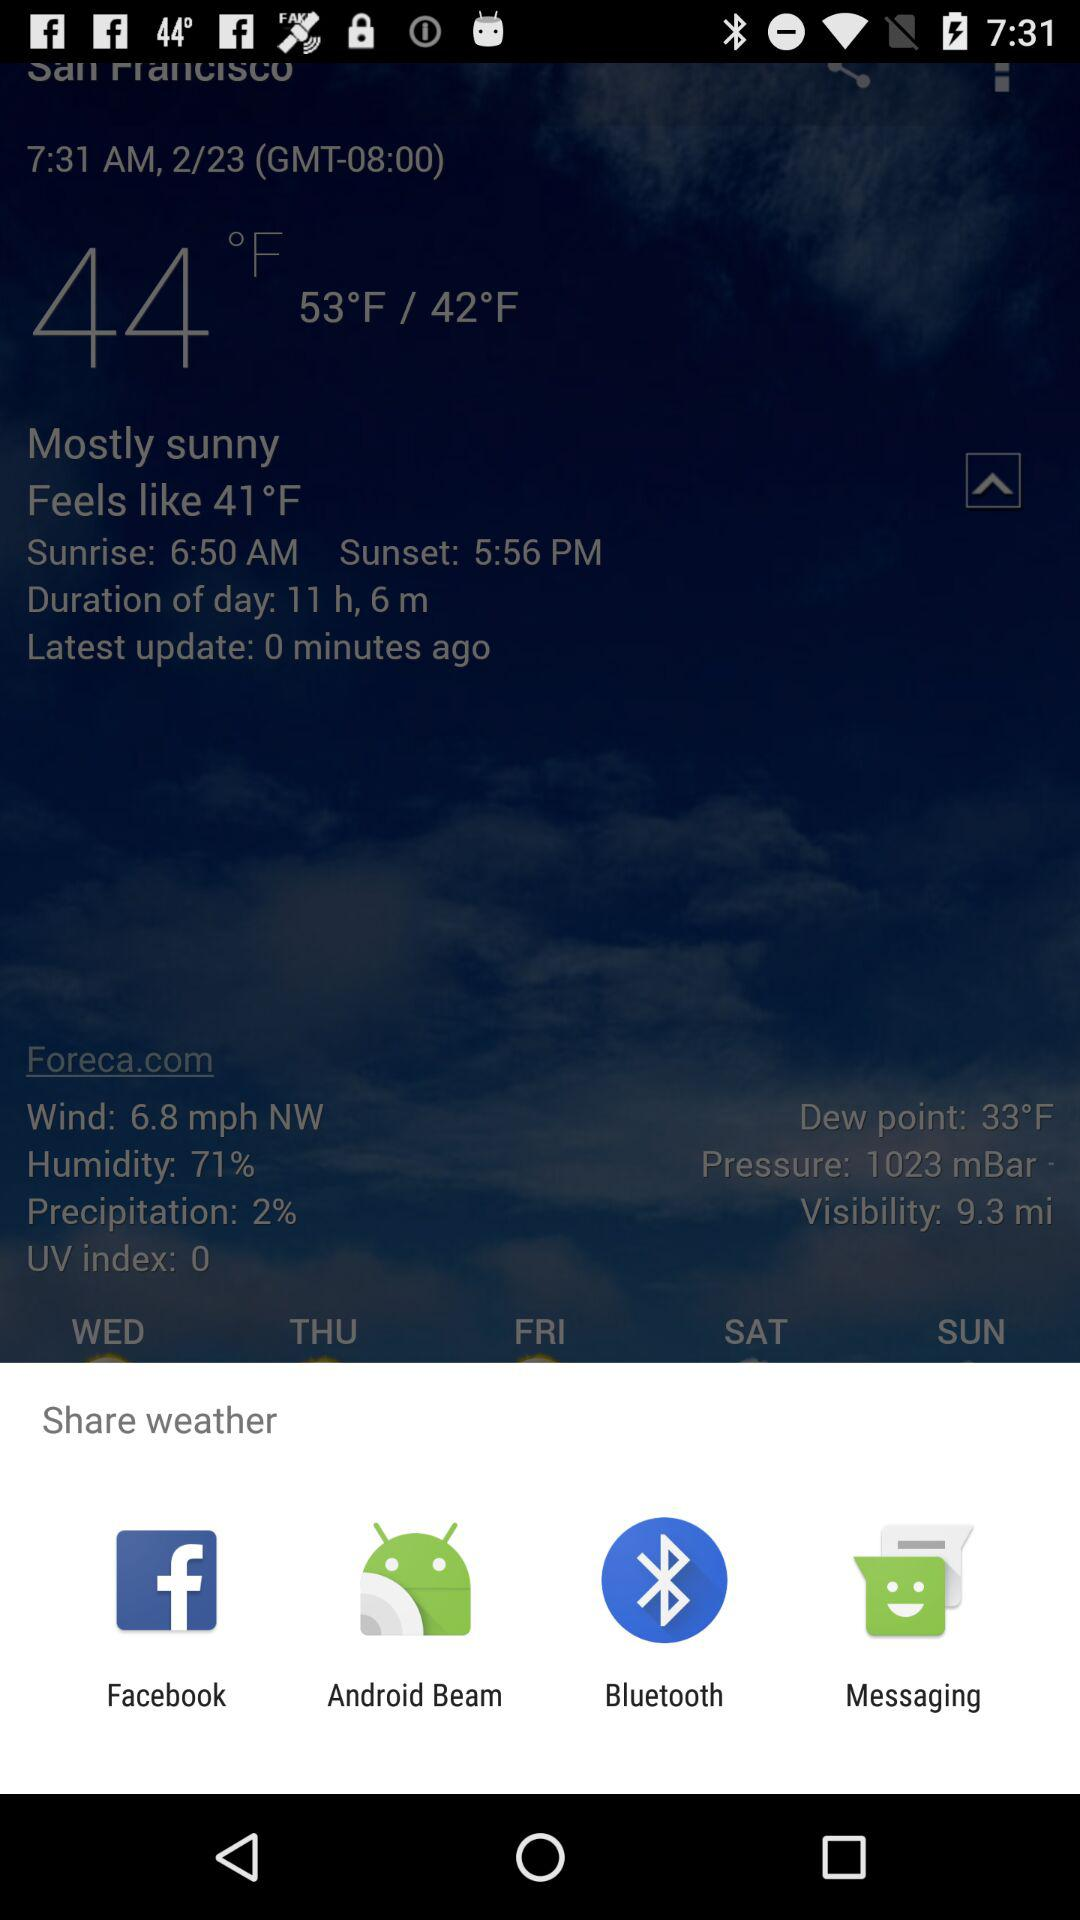How many degrees Fahrenheit is the highest temperature?
Answer the question using a single word or phrase. 53°F 